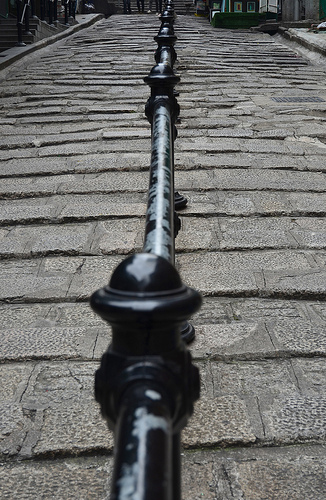<image>
Can you confirm if the sidewalk is next to the rail? Yes. The sidewalk is positioned adjacent to the rail, located nearby in the same general area. 